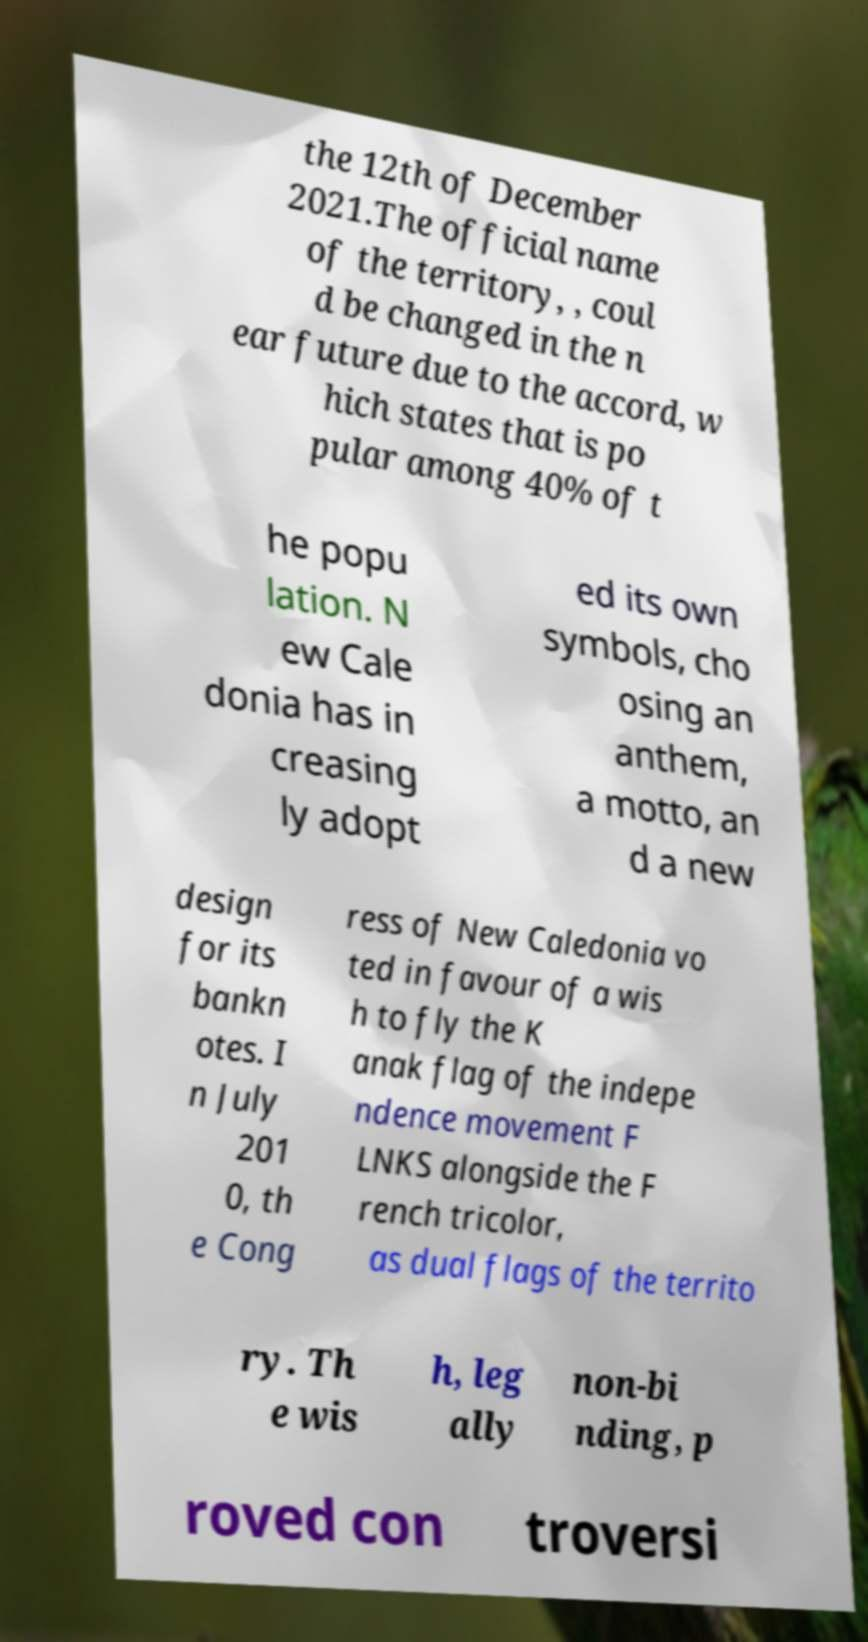Could you extract and type out the text from this image? the 12th of December 2021.The official name of the territory, , coul d be changed in the n ear future due to the accord, w hich states that is po pular among 40% of t he popu lation. N ew Cale donia has in creasing ly adopt ed its own symbols, cho osing an anthem, a motto, an d a new design for its bankn otes. I n July 201 0, th e Cong ress of New Caledonia vo ted in favour of a wis h to fly the K anak flag of the indepe ndence movement F LNKS alongside the F rench tricolor, as dual flags of the territo ry. Th e wis h, leg ally non-bi nding, p roved con troversi 